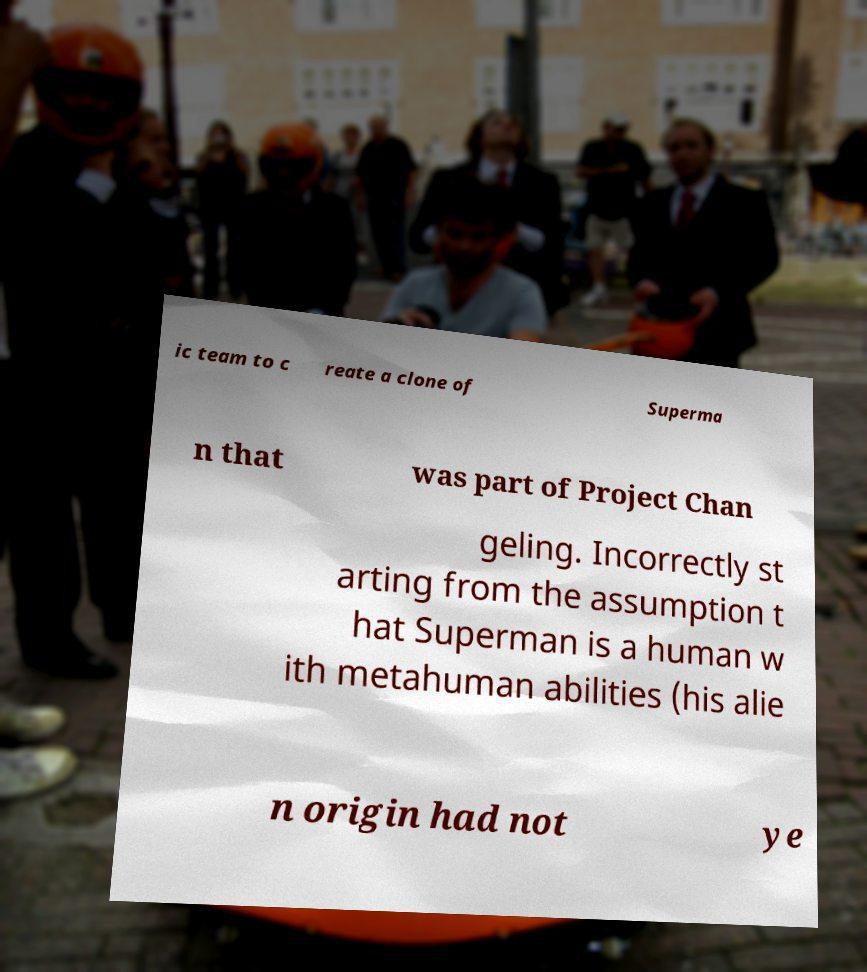Could you assist in decoding the text presented in this image and type it out clearly? ic team to c reate a clone of Superma n that was part of Project Chan geling. Incorrectly st arting from the assumption t hat Superman is a human w ith metahuman abilities (his alie n origin had not ye 